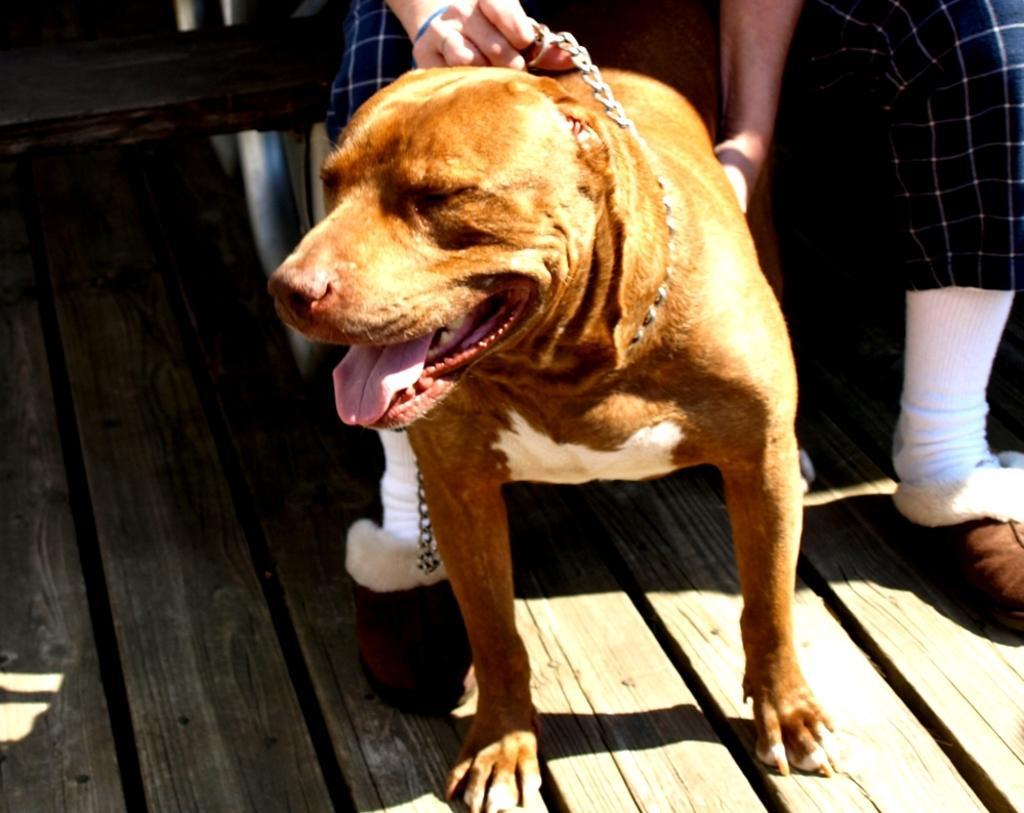Please provide a concise description of this image. In this image we can see dog on a floor. In the background there is a floor and person legs. 